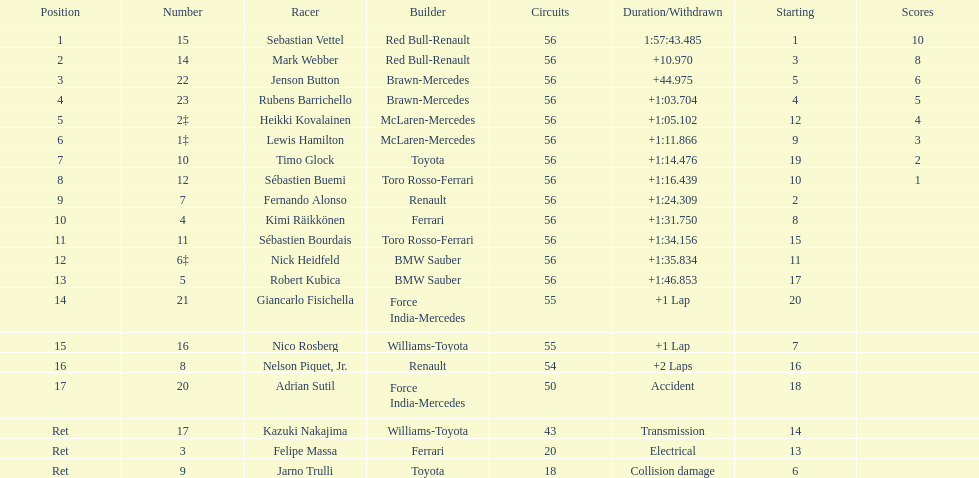Heikki kovalainen and lewis hamilton both had which constructor? McLaren-Mercedes. Can you parse all the data within this table? {'header': ['Position', 'Number', 'Racer', 'Builder', 'Circuits', 'Duration/Withdrawn', 'Starting', 'Scores'], 'rows': [['1', '15', 'Sebastian Vettel', 'Red Bull-Renault', '56', '1:57:43.485', '1', '10'], ['2', '14', 'Mark Webber', 'Red Bull-Renault', '56', '+10.970', '3', '8'], ['3', '22', 'Jenson Button', 'Brawn-Mercedes', '56', '+44.975', '5', '6'], ['4', '23', 'Rubens Barrichello', 'Brawn-Mercedes', '56', '+1:03.704', '4', '5'], ['5', '2‡', 'Heikki Kovalainen', 'McLaren-Mercedes', '56', '+1:05.102', '12', '4'], ['6', '1‡', 'Lewis Hamilton', 'McLaren-Mercedes', '56', '+1:11.866', '9', '3'], ['7', '10', 'Timo Glock', 'Toyota', '56', '+1:14.476', '19', '2'], ['8', '12', 'Sébastien Buemi', 'Toro Rosso-Ferrari', '56', '+1:16.439', '10', '1'], ['9', '7', 'Fernando Alonso', 'Renault', '56', '+1:24.309', '2', ''], ['10', '4', 'Kimi Räikkönen', 'Ferrari', '56', '+1:31.750', '8', ''], ['11', '11', 'Sébastien Bourdais', 'Toro Rosso-Ferrari', '56', '+1:34.156', '15', ''], ['12', '6‡', 'Nick Heidfeld', 'BMW Sauber', '56', '+1:35.834', '11', ''], ['13', '5', 'Robert Kubica', 'BMW Sauber', '56', '+1:46.853', '17', ''], ['14', '21', 'Giancarlo Fisichella', 'Force India-Mercedes', '55', '+1 Lap', '20', ''], ['15', '16', 'Nico Rosberg', 'Williams-Toyota', '55', '+1 Lap', '7', ''], ['16', '8', 'Nelson Piquet, Jr.', 'Renault', '54', '+2 Laps', '16', ''], ['17', '20', 'Adrian Sutil', 'Force India-Mercedes', '50', 'Accident', '18', ''], ['Ret', '17', 'Kazuki Nakajima', 'Williams-Toyota', '43', 'Transmission', '14', ''], ['Ret', '3', 'Felipe Massa', 'Ferrari', '20', 'Electrical', '13', ''], ['Ret', '9', 'Jarno Trulli', 'Toyota', '18', 'Collision damage', '6', '']]} 